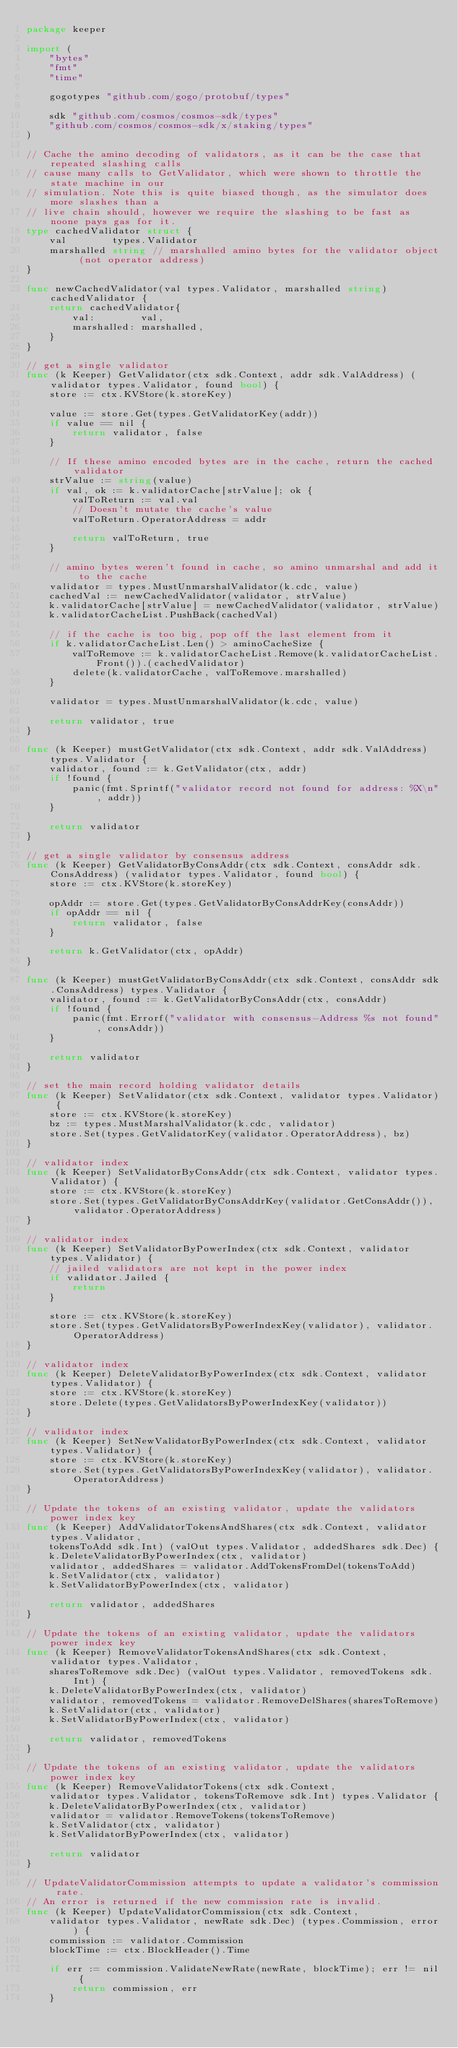Convert code to text. <code><loc_0><loc_0><loc_500><loc_500><_Go_>package keeper

import (
	"bytes"
	"fmt"
	"time"

	gogotypes "github.com/gogo/protobuf/types"

	sdk "github.com/cosmos/cosmos-sdk/types"
	"github.com/cosmos/cosmos-sdk/x/staking/types"
)

// Cache the amino decoding of validators, as it can be the case that repeated slashing calls
// cause many calls to GetValidator, which were shown to throttle the state machine in our
// simulation. Note this is quite biased though, as the simulator does more slashes than a
// live chain should, however we require the slashing to be fast as noone pays gas for it.
type cachedValidator struct {
	val        types.Validator
	marshalled string // marshalled amino bytes for the validator object (not operator address)
}

func newCachedValidator(val types.Validator, marshalled string) cachedValidator {
	return cachedValidator{
		val:        val,
		marshalled: marshalled,
	}
}

// get a single validator
func (k Keeper) GetValidator(ctx sdk.Context, addr sdk.ValAddress) (validator types.Validator, found bool) {
	store := ctx.KVStore(k.storeKey)

	value := store.Get(types.GetValidatorKey(addr))
	if value == nil {
		return validator, false
	}

	// If these amino encoded bytes are in the cache, return the cached validator
	strValue := string(value)
	if val, ok := k.validatorCache[strValue]; ok {
		valToReturn := val.val
		// Doesn't mutate the cache's value
		valToReturn.OperatorAddress = addr

		return valToReturn, true
	}

	// amino bytes weren't found in cache, so amino unmarshal and add it to the cache
	validator = types.MustUnmarshalValidator(k.cdc, value)
	cachedVal := newCachedValidator(validator, strValue)
	k.validatorCache[strValue] = newCachedValidator(validator, strValue)
	k.validatorCacheList.PushBack(cachedVal)

	// if the cache is too big, pop off the last element from it
	if k.validatorCacheList.Len() > aminoCacheSize {
		valToRemove := k.validatorCacheList.Remove(k.validatorCacheList.Front()).(cachedValidator)
		delete(k.validatorCache, valToRemove.marshalled)
	}

	validator = types.MustUnmarshalValidator(k.cdc, value)

	return validator, true
}

func (k Keeper) mustGetValidator(ctx sdk.Context, addr sdk.ValAddress) types.Validator {
	validator, found := k.GetValidator(ctx, addr)
	if !found {
		panic(fmt.Sprintf("validator record not found for address: %X\n", addr))
	}

	return validator
}

// get a single validator by consensus address
func (k Keeper) GetValidatorByConsAddr(ctx sdk.Context, consAddr sdk.ConsAddress) (validator types.Validator, found bool) {
	store := ctx.KVStore(k.storeKey)

	opAddr := store.Get(types.GetValidatorByConsAddrKey(consAddr))
	if opAddr == nil {
		return validator, false
	}

	return k.GetValidator(ctx, opAddr)
}

func (k Keeper) mustGetValidatorByConsAddr(ctx sdk.Context, consAddr sdk.ConsAddress) types.Validator {
	validator, found := k.GetValidatorByConsAddr(ctx, consAddr)
	if !found {
		panic(fmt.Errorf("validator with consensus-Address %s not found", consAddr))
	}

	return validator
}

// set the main record holding validator details
func (k Keeper) SetValidator(ctx sdk.Context, validator types.Validator) {
	store := ctx.KVStore(k.storeKey)
	bz := types.MustMarshalValidator(k.cdc, validator)
	store.Set(types.GetValidatorKey(validator.OperatorAddress), bz)
}

// validator index
func (k Keeper) SetValidatorByConsAddr(ctx sdk.Context, validator types.Validator) {
	store := ctx.KVStore(k.storeKey)
	store.Set(types.GetValidatorByConsAddrKey(validator.GetConsAddr()), validator.OperatorAddress)
}

// validator index
func (k Keeper) SetValidatorByPowerIndex(ctx sdk.Context, validator types.Validator) {
	// jailed validators are not kept in the power index
	if validator.Jailed {
		return
	}

	store := ctx.KVStore(k.storeKey)
	store.Set(types.GetValidatorsByPowerIndexKey(validator), validator.OperatorAddress)
}

// validator index
func (k Keeper) DeleteValidatorByPowerIndex(ctx sdk.Context, validator types.Validator) {
	store := ctx.KVStore(k.storeKey)
	store.Delete(types.GetValidatorsByPowerIndexKey(validator))
}

// validator index
func (k Keeper) SetNewValidatorByPowerIndex(ctx sdk.Context, validator types.Validator) {
	store := ctx.KVStore(k.storeKey)
	store.Set(types.GetValidatorsByPowerIndexKey(validator), validator.OperatorAddress)
}

// Update the tokens of an existing validator, update the validators power index key
func (k Keeper) AddValidatorTokensAndShares(ctx sdk.Context, validator types.Validator,
	tokensToAdd sdk.Int) (valOut types.Validator, addedShares sdk.Dec) {
	k.DeleteValidatorByPowerIndex(ctx, validator)
	validator, addedShares = validator.AddTokensFromDel(tokensToAdd)
	k.SetValidator(ctx, validator)
	k.SetValidatorByPowerIndex(ctx, validator)

	return validator, addedShares
}

// Update the tokens of an existing validator, update the validators power index key
func (k Keeper) RemoveValidatorTokensAndShares(ctx sdk.Context, validator types.Validator,
	sharesToRemove sdk.Dec) (valOut types.Validator, removedTokens sdk.Int) {
	k.DeleteValidatorByPowerIndex(ctx, validator)
	validator, removedTokens = validator.RemoveDelShares(sharesToRemove)
	k.SetValidator(ctx, validator)
	k.SetValidatorByPowerIndex(ctx, validator)

	return validator, removedTokens
}

// Update the tokens of an existing validator, update the validators power index key
func (k Keeper) RemoveValidatorTokens(ctx sdk.Context,
	validator types.Validator, tokensToRemove sdk.Int) types.Validator {
	k.DeleteValidatorByPowerIndex(ctx, validator)
	validator = validator.RemoveTokens(tokensToRemove)
	k.SetValidator(ctx, validator)
	k.SetValidatorByPowerIndex(ctx, validator)

	return validator
}

// UpdateValidatorCommission attempts to update a validator's commission rate.
// An error is returned if the new commission rate is invalid.
func (k Keeper) UpdateValidatorCommission(ctx sdk.Context,
	validator types.Validator, newRate sdk.Dec) (types.Commission, error) {
	commission := validator.Commission
	blockTime := ctx.BlockHeader().Time

	if err := commission.ValidateNewRate(newRate, blockTime); err != nil {
		return commission, err
	}
</code> 